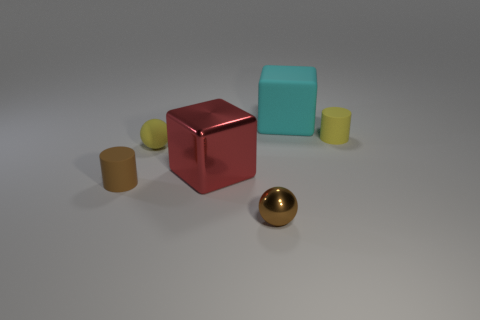Is the number of large matte blocks in front of the big cyan object greater than the number of shiny cubes that are in front of the red metallic thing?
Your answer should be very brief. No. What number of matte things are either small things or gray cylinders?
Offer a very short reply. 3. What is the shape of the tiny object that is the same color as the tiny matte sphere?
Your answer should be compact. Cylinder. There is a tiny brown object right of the tiny brown rubber cylinder; what is it made of?
Give a very brief answer. Metal. How many things are red blocks or cubes that are to the left of the large rubber cube?
Offer a very short reply. 1. The rubber object that is the same size as the metallic block is what shape?
Give a very brief answer. Cube. How many blocks have the same color as the small matte ball?
Offer a terse response. 0. Does the tiny cylinder behind the brown cylinder have the same material as the large red block?
Offer a terse response. No. What shape is the red metallic object?
Your response must be concise. Cube. How many blue things are tiny matte balls or large blocks?
Provide a short and direct response. 0. 